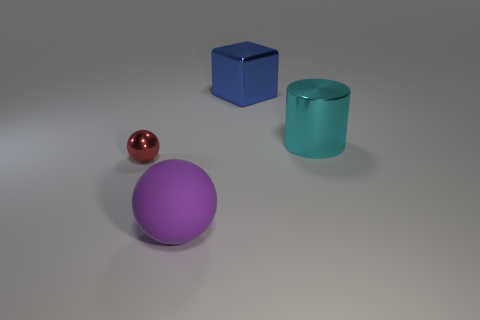What number of large spheres have the same material as the tiny red ball?
Make the answer very short. 0. What number of metallic objects are red objects or blue objects?
Provide a short and direct response. 2. There is a cyan thing that is the same size as the purple rubber ball; what is it made of?
Your response must be concise. Metal. Are there any purple objects that have the same material as the big ball?
Keep it short and to the point. No. The big object in front of the object that is right of the object behind the cyan cylinder is what shape?
Your answer should be very brief. Sphere. Do the cyan metal cylinder and the metallic thing that is to the left of the blue thing have the same size?
Offer a very short reply. No. There is a large object that is in front of the large blue cube and behind the small red metal sphere; what shape is it?
Your answer should be very brief. Cylinder. What number of big objects are either red spheres or blue balls?
Your answer should be very brief. 0. Are there an equal number of objects on the right side of the large cyan cylinder and big balls left of the purple matte thing?
Give a very brief answer. Yes. How many other objects are there of the same color as the small sphere?
Ensure brevity in your answer.  0. 